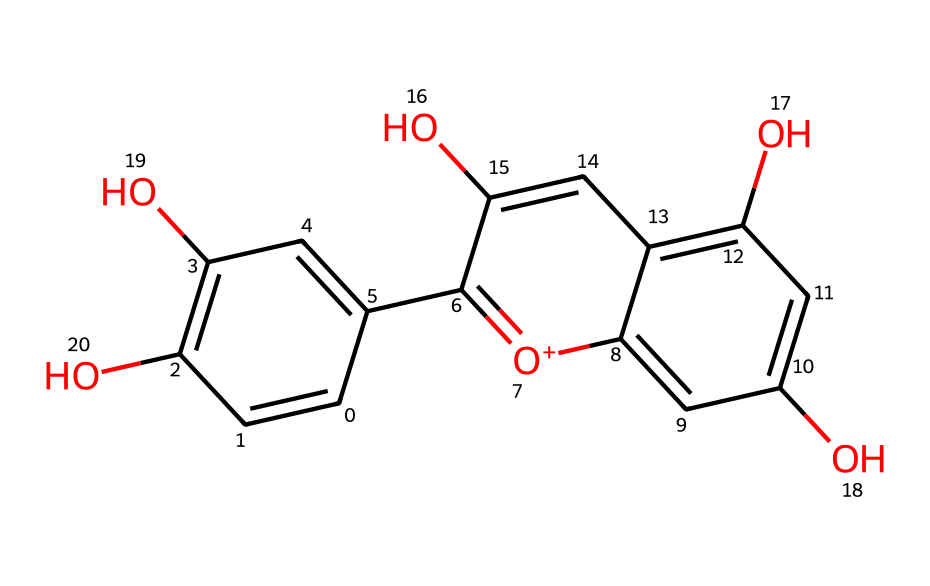What is the main functional group in this chemical structure? The chemical structure contains multiple hydroxyl groups (OH), which are indicative of phenolic compounds. This makes the hydroxyl group the main functional group present.
Answer: hydroxyl How many rings are present in this chemical? The provided SMILES representation reveals two distinct aromatic rings that are fused together, indicating that there are two rings present.
Answer: two Which element is central to the structure of anthocyanins, contributing to their antioxidant properties? The structure contains oxygen atoms prominently in hydroxyl and carbonyl types, which are essential for the antioxidant properties. These elements contribute to the capture of free radicals.
Answer: oxygen What is the relative position of the hydroxyl groups in this structure? The hydroxyl groups are located in ortho and para positions relative to the other substituents on the aromatic rings, providing stability and solubility in polar solvents.
Answer: ortho and para What is the potential impact of the multiple hydroxyl groups on the chemical's properties? The presence of multiple hydroxyl groups enhances the solubility in water and improves antioxidant activity due to their ability to donate hydrogen. This impacts the overall reactivity of the molecule.
Answer: enhances solubility and reactivity 